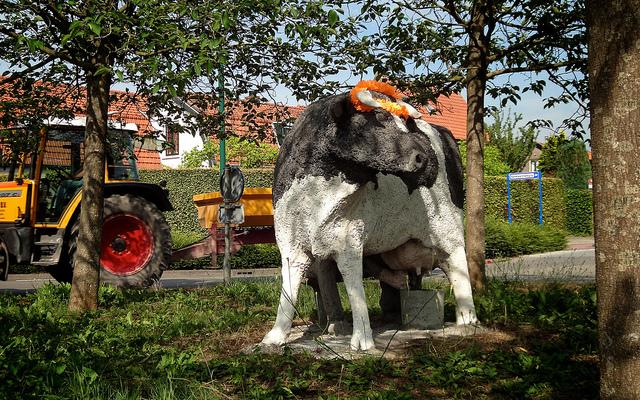Sunny or overcast?
Concise answer only. Sunny. Is this a statue or a live animal?
Concise answer only. Statue. Are trees visible?
Short answer required. Yes. 